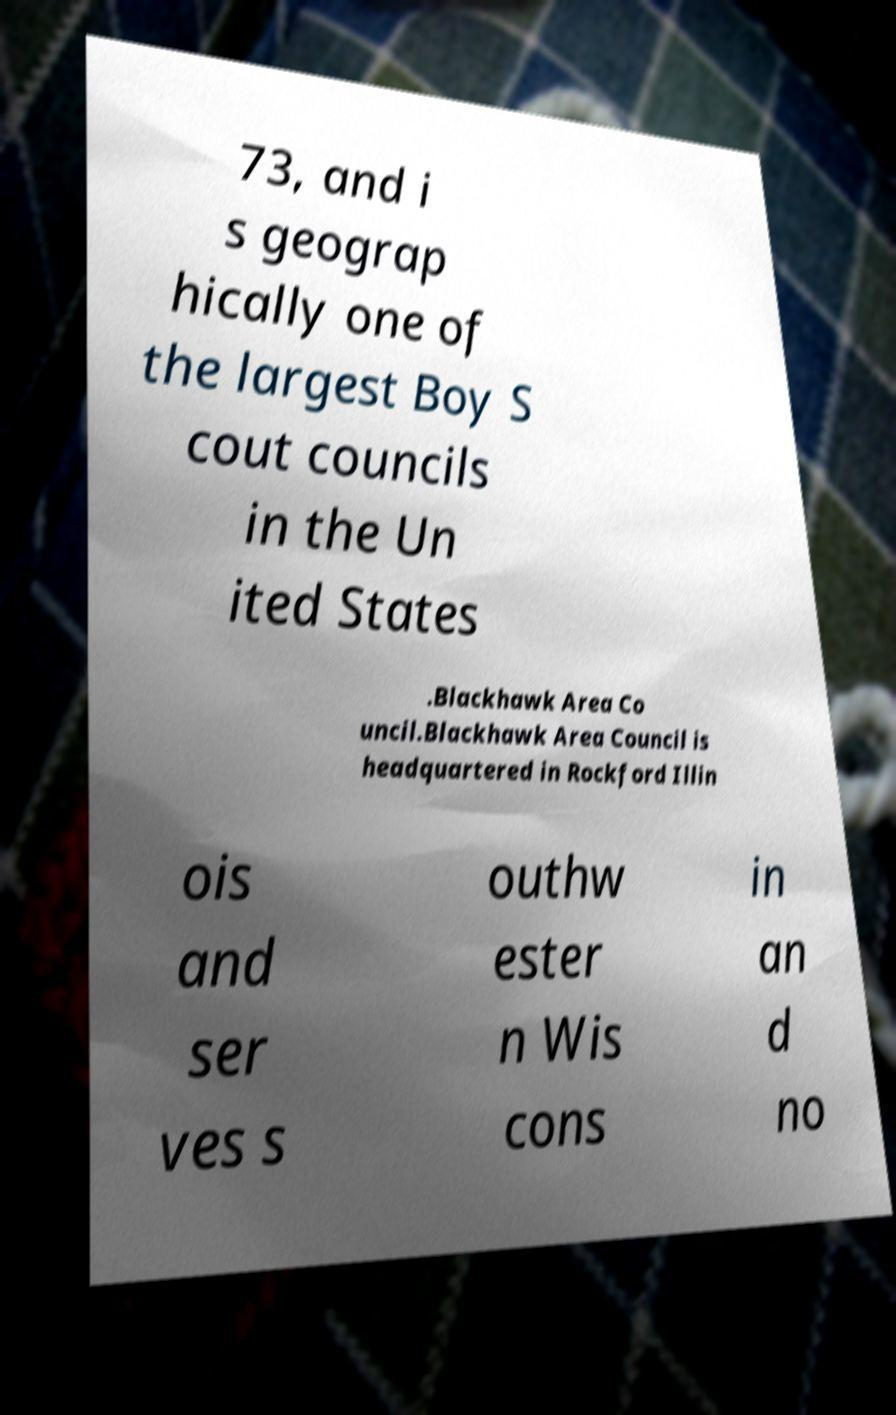Could you extract and type out the text from this image? 73, and i s geograp hically one of the largest Boy S cout councils in the Un ited States .Blackhawk Area Co uncil.Blackhawk Area Council is headquartered in Rockford Illin ois and ser ves s outhw ester n Wis cons in an d no 